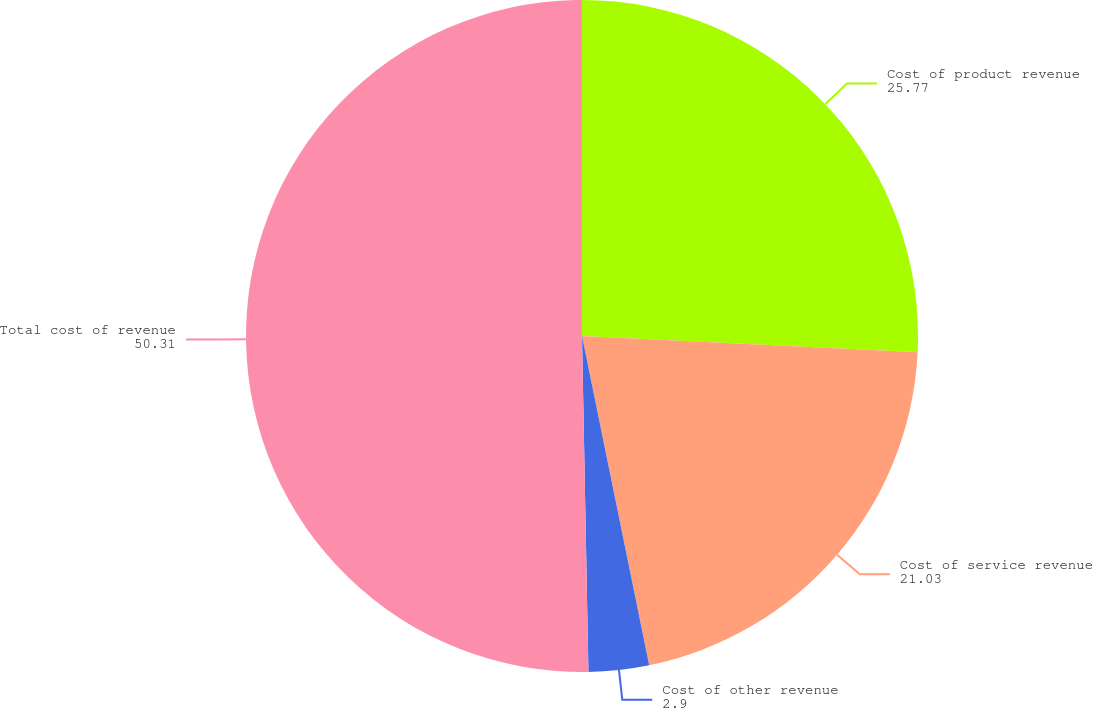Convert chart to OTSL. <chart><loc_0><loc_0><loc_500><loc_500><pie_chart><fcel>Cost of product revenue<fcel>Cost of service revenue<fcel>Cost of other revenue<fcel>Total cost of revenue<nl><fcel>25.77%<fcel>21.03%<fcel>2.9%<fcel>50.31%<nl></chart> 